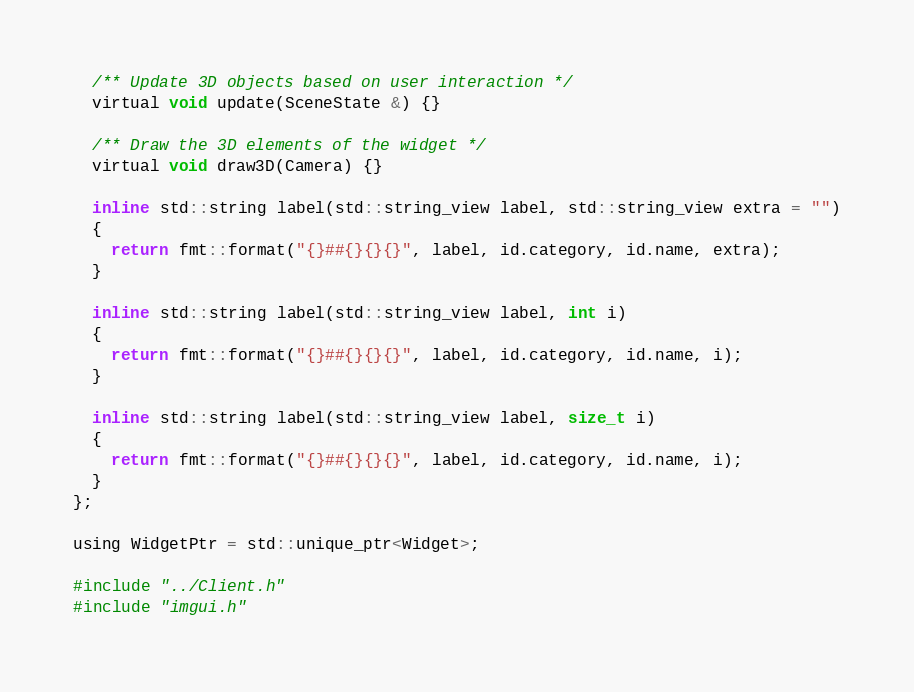<code> <loc_0><loc_0><loc_500><loc_500><_C_>
  /** Update 3D objects based on user interaction */
  virtual void update(SceneState &) {}

  /** Draw the 3D elements of the widget */
  virtual void draw3D(Camera) {}

  inline std::string label(std::string_view label, std::string_view extra = "")
  {
    return fmt::format("{}##{}{}{}", label, id.category, id.name, extra);
  }

  inline std::string label(std::string_view label, int i)
  {
    return fmt::format("{}##{}{}{}", label, id.category, id.name, i);
  }

  inline std::string label(std::string_view label, size_t i)
  {
    return fmt::format("{}##{}{}{}", label, id.category, id.name, i);
  }
};

using WidgetPtr = std::unique_ptr<Widget>;

#include "../Client.h"
#include "imgui.h"
</code> 